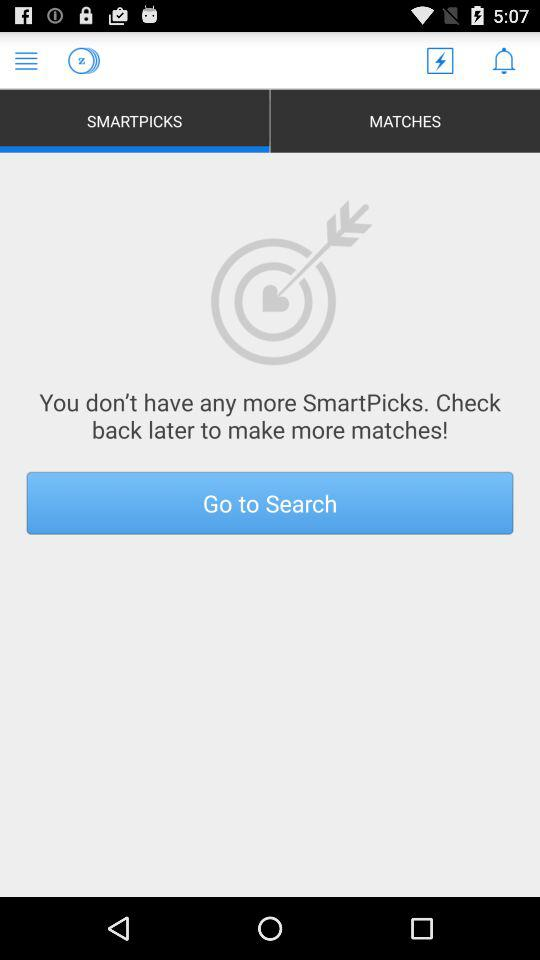Are there any "SmartPicks"? There are no "SmartPicks". 